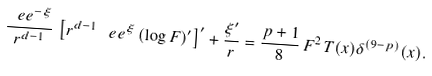Convert formula to latex. <formula><loc_0><loc_0><loc_500><loc_500>\frac { \ e e ^ { - \xi } } { r ^ { d - 1 } } \, \left [ r ^ { d - 1 } \, \ e e ^ { \xi } \, ( \log F ) ^ { \prime } \right ] ^ { \prime } + \frac { \xi ^ { \prime } } { r } = \frac { p + 1 } { 8 } \, F ^ { 2 } \, T ( x ) \delta ^ { ( 9 - p ) } ( x ) .</formula> 